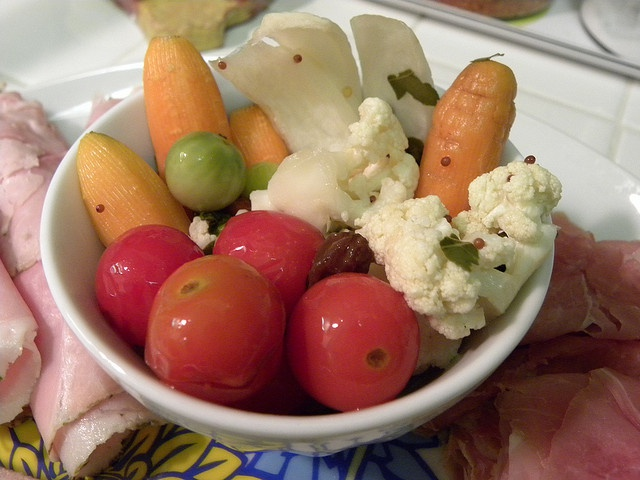Describe the objects in this image and their specific colors. I can see bowl in lightgray, tan, brown, and maroon tones, broccoli in lightgray, tan, and olive tones, carrot in lightgray, red, tan, and salmon tones, carrot in lightgray, orange, and red tones, and carrot in lightgray, olive, and orange tones in this image. 